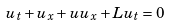<formula> <loc_0><loc_0><loc_500><loc_500>u _ { t } + u _ { x } + u u _ { x } + L u _ { t } = 0</formula> 